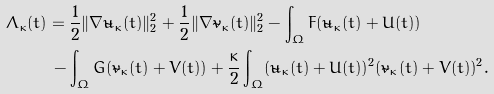<formula> <loc_0><loc_0><loc_500><loc_500>\Lambda _ { \kappa } ( t ) & = \frac { 1 } { 2 } \| \nabla \tilde { u } _ { \kappa } ( t ) \| _ { 2 } ^ { 2 } + \frac { 1 } { 2 } \| \nabla \tilde { v } _ { \kappa } ( t ) \| _ { 2 } ^ { 2 } - \int _ { \Omega } F ( \tilde { u } _ { \kappa } ( t ) + U ( t ) ) \\ & \, - \int _ { \Omega } G ( \tilde { v } _ { \kappa } ( t ) + V ( t ) ) + \frac { \kappa } { 2 } \int _ { \Omega } ( \tilde { u } _ { \kappa } ( t ) + U ( t ) ) ^ { 2 } ( \tilde { v } _ { \kappa } ( t ) + V ( t ) ) ^ { 2 } .</formula> 